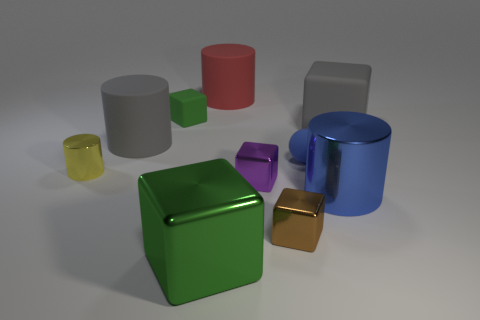Subtract 1 cubes. How many cubes are left? 4 Subtract all gray cylinders. Subtract all gray spheres. How many cylinders are left? 3 Subtract all cylinders. How many objects are left? 6 Subtract 1 gray cubes. How many objects are left? 9 Subtract all large objects. Subtract all yellow metallic cylinders. How many objects are left? 4 Add 8 big gray cylinders. How many big gray cylinders are left? 9 Add 7 small yellow matte cylinders. How many small yellow matte cylinders exist? 7 